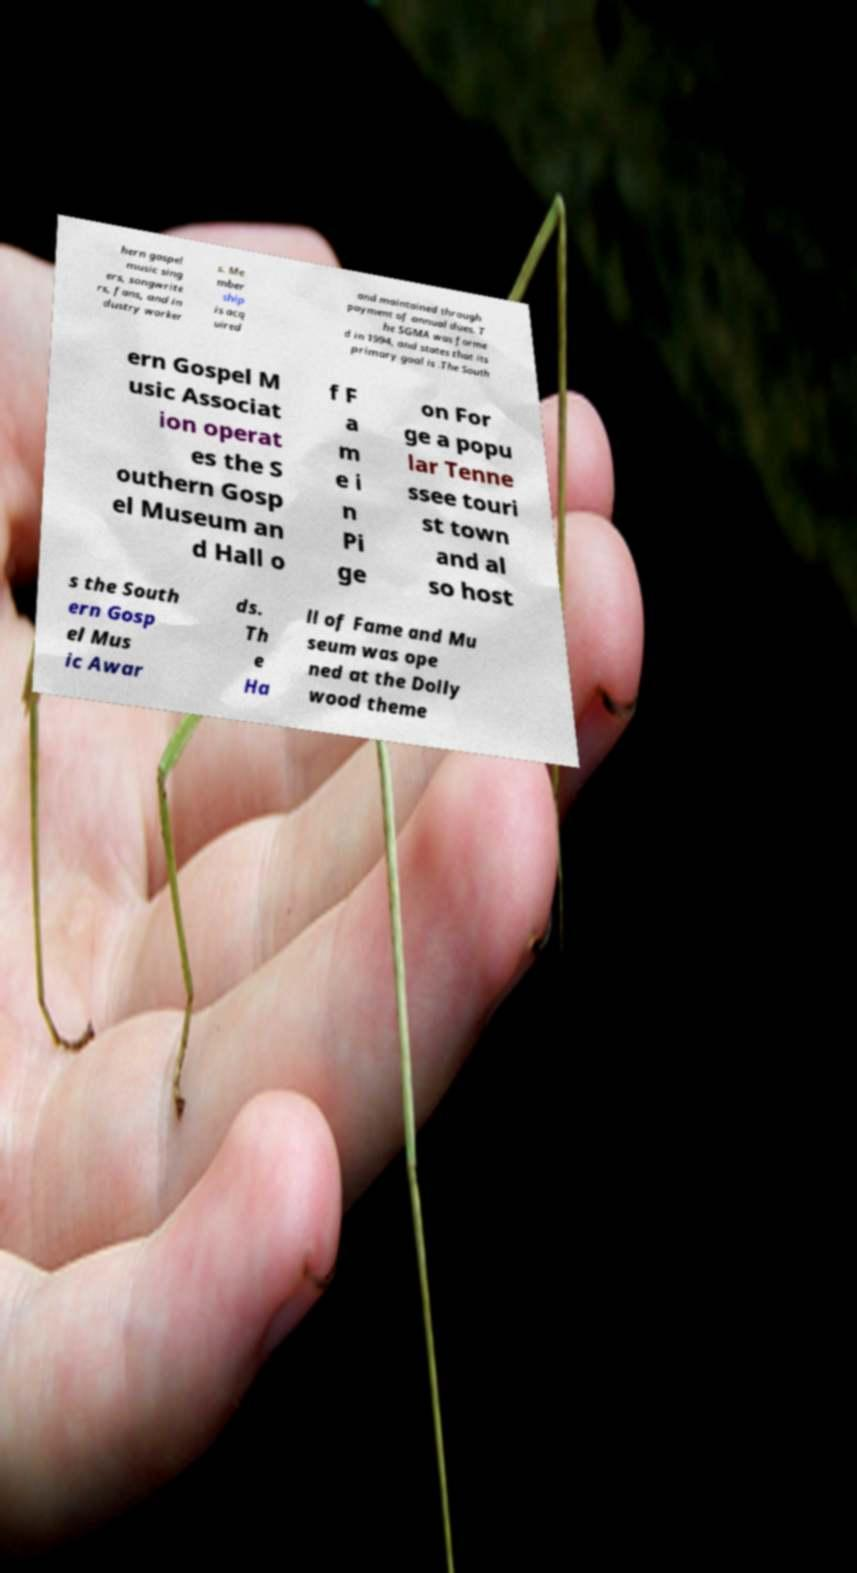Please identify and transcribe the text found in this image. hern gospel music sing ers, songwrite rs, fans, and in dustry worker s. Me mber ship is acq uired and maintained through payment of annual dues. T he SGMA was forme d in 1994, and states that its primary goal is .The South ern Gospel M usic Associat ion operat es the S outhern Gosp el Museum an d Hall o f F a m e i n Pi ge on For ge a popu lar Tenne ssee touri st town and al so host s the South ern Gosp el Mus ic Awar ds. Th e Ha ll of Fame and Mu seum was ope ned at the Dolly wood theme 